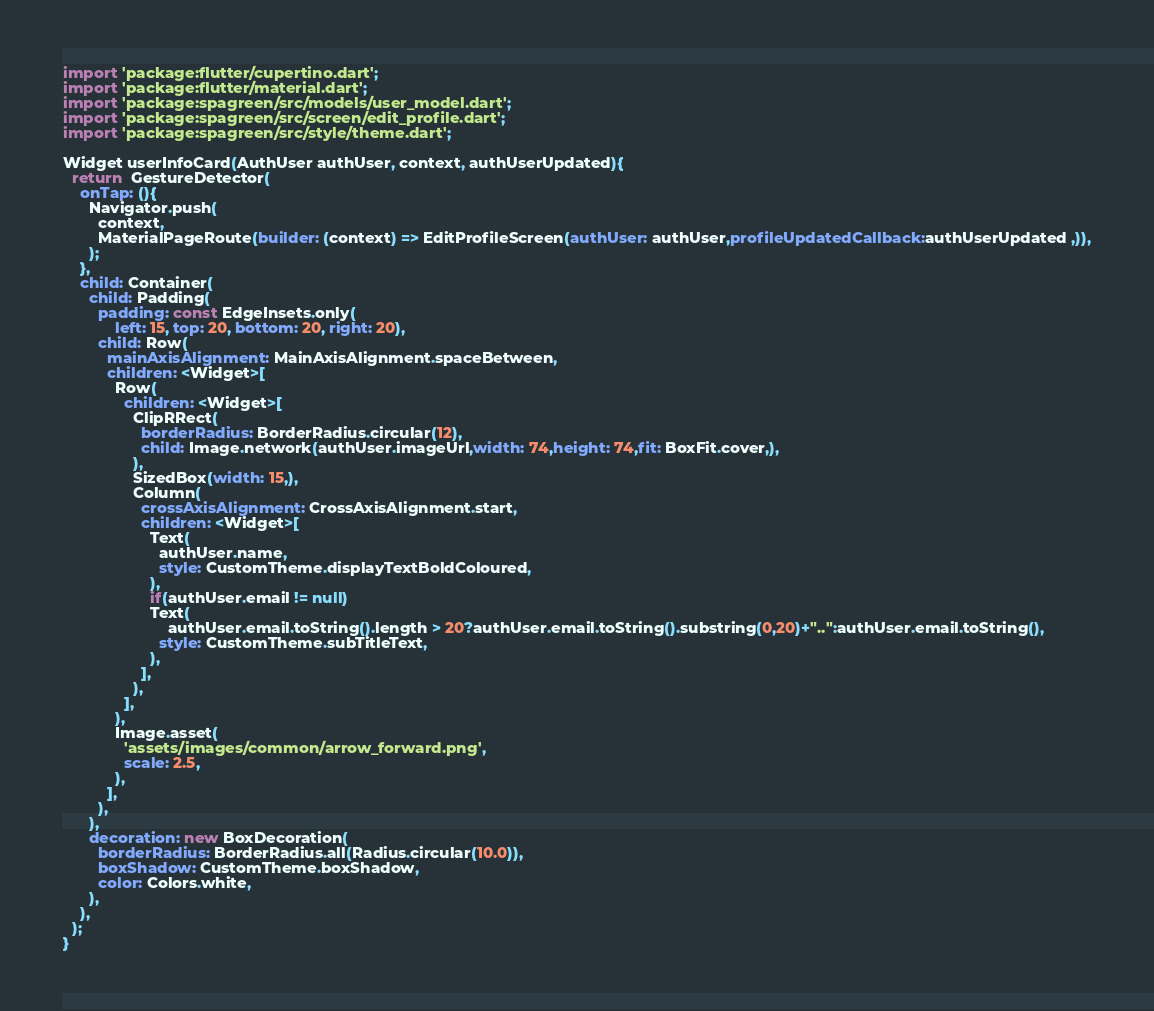<code> <loc_0><loc_0><loc_500><loc_500><_Dart_>import 'package:flutter/cupertino.dart';
import 'package:flutter/material.dart';
import 'package:spagreen/src/models/user_model.dart';
import 'package:spagreen/src/screen/edit_profile.dart';
import 'package:spagreen/src/style/theme.dart';

Widget userInfoCard(AuthUser authUser, context, authUserUpdated){
  return  GestureDetector(
    onTap: (){
      Navigator.push(
        context,
        MaterialPageRoute(builder: (context) => EditProfileScreen(authUser: authUser,profileUpdatedCallback:authUserUpdated ,)),
      );
    },
    child: Container(
      child: Padding(
        padding: const EdgeInsets.only(
            left: 15, top: 20, bottom: 20, right: 20),
        child: Row(
          mainAxisAlignment: MainAxisAlignment.spaceBetween,
          children: <Widget>[
            Row(
              children: <Widget>[
                ClipRRect(
                  borderRadius: BorderRadius.circular(12),
                  child: Image.network(authUser.imageUrl,width: 74,height: 74,fit: BoxFit.cover,),
                ),
                SizedBox(width: 15,),
                Column(
                  crossAxisAlignment: CrossAxisAlignment.start,
                  children: <Widget>[
                    Text(
                      authUser.name,
                      style: CustomTheme.displayTextBoldColoured,
                    ),
                    if(authUser.email != null)
                    Text(
                        authUser.email.toString().length > 20?authUser.email.toString().substring(0,20)+"..":authUser.email.toString(),
                      style: CustomTheme.subTitleText,
                    ),
                  ],
                ),
              ],
            ),
            Image.asset(
              'assets/images/common/arrow_forward.png',
              scale: 2.5,
            ),
          ],
        ),
      ),
      decoration: new BoxDecoration(
        borderRadius: BorderRadius.all(Radius.circular(10.0)),
        boxShadow: CustomTheme.boxShadow,
        color: Colors.white,
      ),
    ),
  );
}</code> 